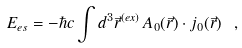<formula> <loc_0><loc_0><loc_500><loc_500>E _ { e s } = - \hbar { c } \int d ^ { 3 } \vec { r } ^ { ( e x ) } \, A _ { 0 } ( \vec { r } ) \cdot j _ { 0 } ( \vec { r } ) \ ,</formula> 